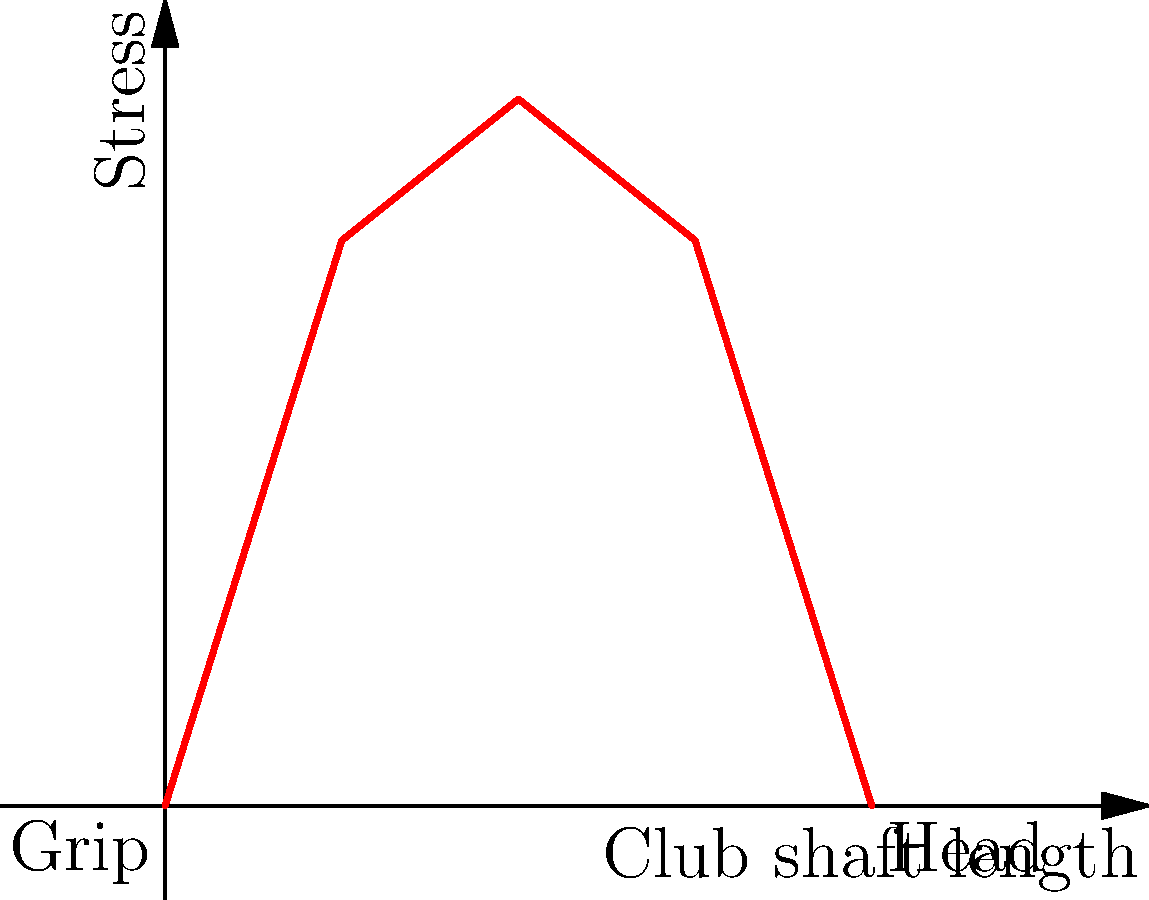During a golf swing, the stress distribution along the club shaft is not uniform. Based on your experience and knowledge of golf club dynamics, which part of the shaft typically experiences the highest stress, and why is this understanding crucial for club design and performance? To answer this question, we need to consider the mechanics of a golf swing and the properties of the club shaft:

1. Golf swing mechanics:
   - The swing involves a rapid acceleration and deceleration.
   - The club head travels the greatest distance and reaches the highest velocity.

2. Club shaft properties:
   - The shaft is typically tapered, being thicker at the grip end and thinner towards the club head.
   - It's designed to flex during the swing, storing and releasing energy.

3. Stress distribution:
   - The stress in the shaft is not uniform due to the varying thickness and the dynamics of the swing.
   - The middle section of the shaft experiences the highest stress because:
     a) It's thinner than the grip end, making it more susceptible to bending.
     b) It's farther from the grip, experiencing more force from the moving club head.
     c) The rapid acceleration and deceleration create a whipping effect, concentrating stress in this area.

4. Importance for club design and performance:
   - Understanding stress distribution helps in:
     a) Material selection: Choosing materials that can withstand the peak stress.
     b) Shaft design: Optimizing the tapering and flexibility for better performance.
     c) Durability: Ensuring the club can withstand repeated use without failure.
     d) Performance: Maximizing energy transfer from the swing to the ball.

The graph shows a typical stress distribution along the shaft length, with the peak occurring in the middle section.
Answer: Middle section; crucial for material selection, shaft design, durability, and performance optimization. 